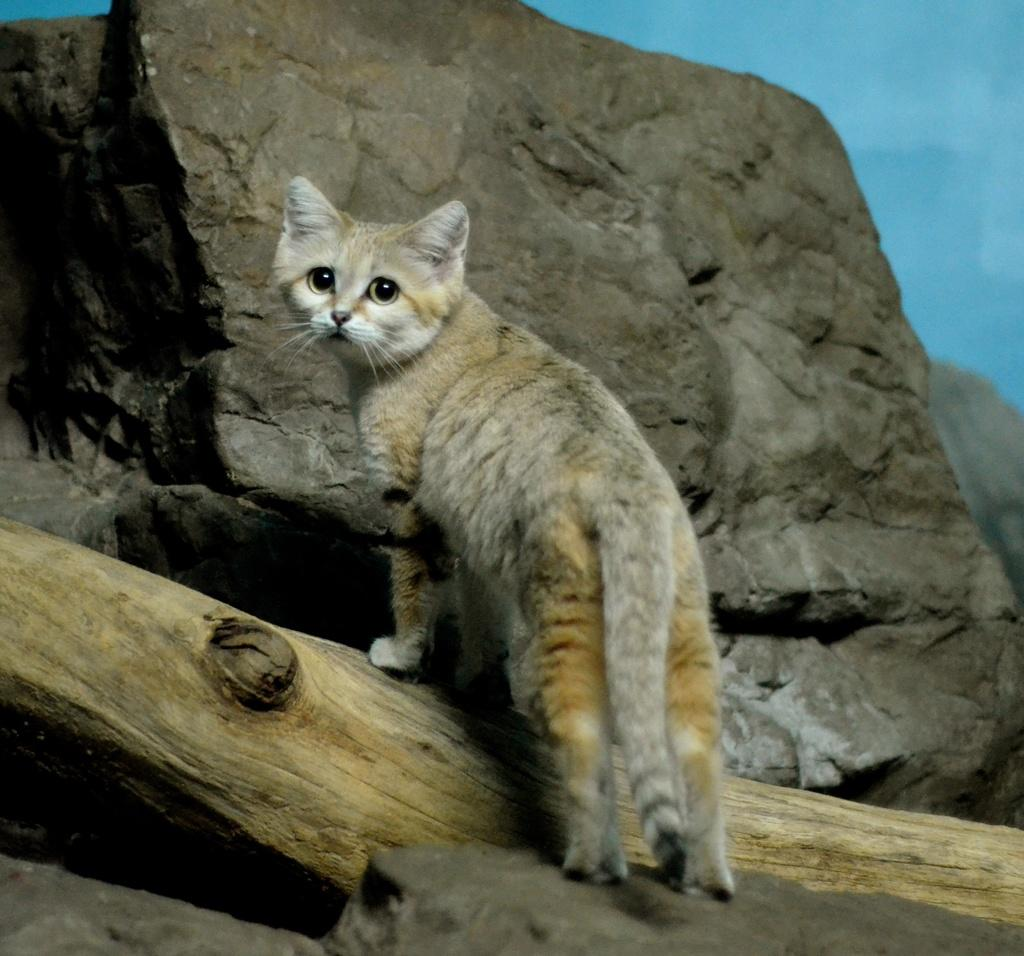What type of animal is in the image? There is a cat in the image. What other object can be seen in the image? There is a rock in the image. What is visible in the background of the image? The sky is visible in the background of the image. What type of corn is growing in the image? There is no corn present in the image; it features a cat and a rock with a sky background. 